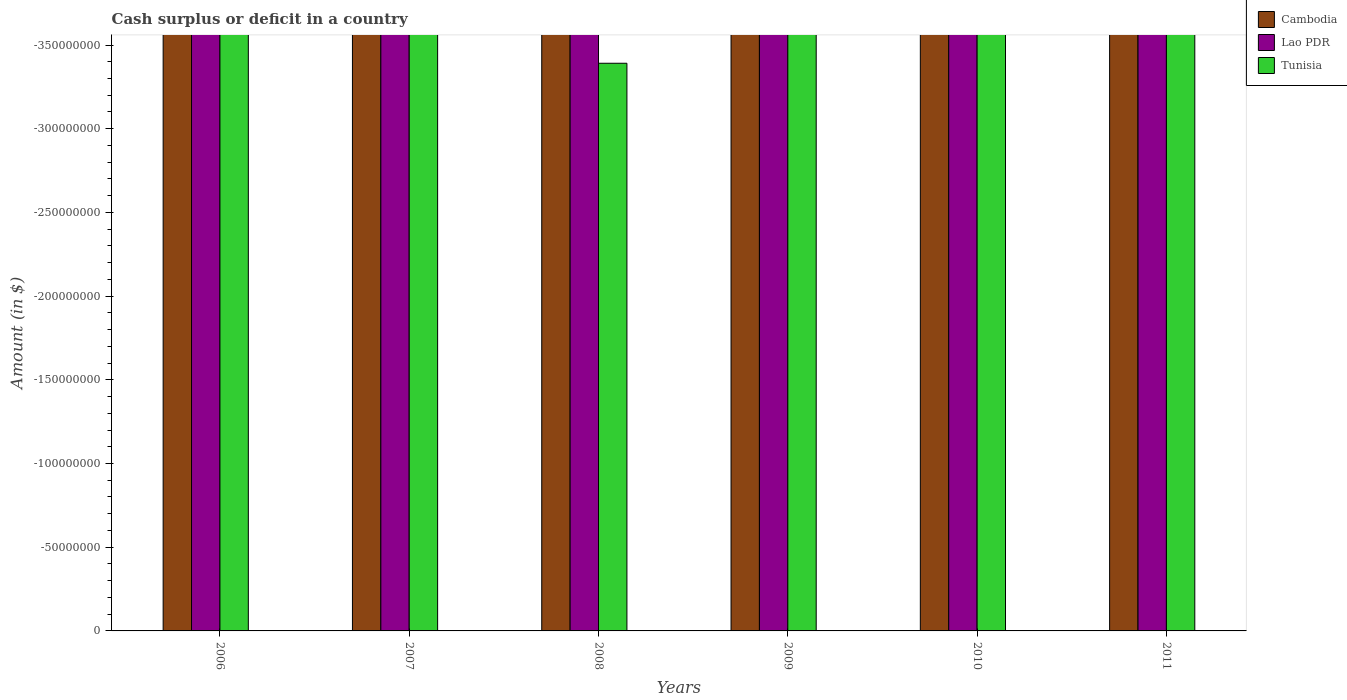Are the number of bars per tick equal to the number of legend labels?
Provide a short and direct response. No. How many bars are there on the 5th tick from the right?
Offer a terse response. 0. What is the label of the 6th group of bars from the left?
Provide a succinct answer. 2011. What is the difference between the amount of cash surplus or deficit in Cambodia in 2007 and the amount of cash surplus or deficit in Tunisia in 2006?
Provide a succinct answer. 0. In how many years, is the amount of cash surplus or deficit in Cambodia greater than -30000000 $?
Give a very brief answer. 0. In how many years, is the amount of cash surplus or deficit in Lao PDR greater than the average amount of cash surplus or deficit in Lao PDR taken over all years?
Provide a succinct answer. 0. Is it the case that in every year, the sum of the amount of cash surplus or deficit in Lao PDR and amount of cash surplus or deficit in Cambodia is greater than the amount of cash surplus or deficit in Tunisia?
Give a very brief answer. No. How many bars are there?
Provide a succinct answer. 0. What is the difference between two consecutive major ticks on the Y-axis?
Your answer should be very brief. 5.00e+07. Are the values on the major ticks of Y-axis written in scientific E-notation?
Your response must be concise. No. Where does the legend appear in the graph?
Make the answer very short. Top right. How many legend labels are there?
Offer a very short reply. 3. How are the legend labels stacked?
Provide a succinct answer. Vertical. What is the title of the graph?
Give a very brief answer. Cash surplus or deficit in a country. What is the label or title of the Y-axis?
Give a very brief answer. Amount (in $). What is the Amount (in $) of Cambodia in 2006?
Your response must be concise. 0. What is the Amount (in $) of Tunisia in 2006?
Provide a succinct answer. 0. What is the Amount (in $) of Cambodia in 2007?
Provide a succinct answer. 0. What is the Amount (in $) in Lao PDR in 2008?
Provide a short and direct response. 0. What is the Amount (in $) in Tunisia in 2008?
Your answer should be very brief. 0. What is the Amount (in $) in Cambodia in 2009?
Make the answer very short. 0. What is the Amount (in $) of Tunisia in 2009?
Ensure brevity in your answer.  0. What is the Amount (in $) in Lao PDR in 2010?
Offer a terse response. 0. What is the Amount (in $) of Tunisia in 2010?
Make the answer very short. 0. What is the Amount (in $) in Lao PDR in 2011?
Ensure brevity in your answer.  0. What is the average Amount (in $) in Cambodia per year?
Your response must be concise. 0. What is the average Amount (in $) of Tunisia per year?
Offer a very short reply. 0. 